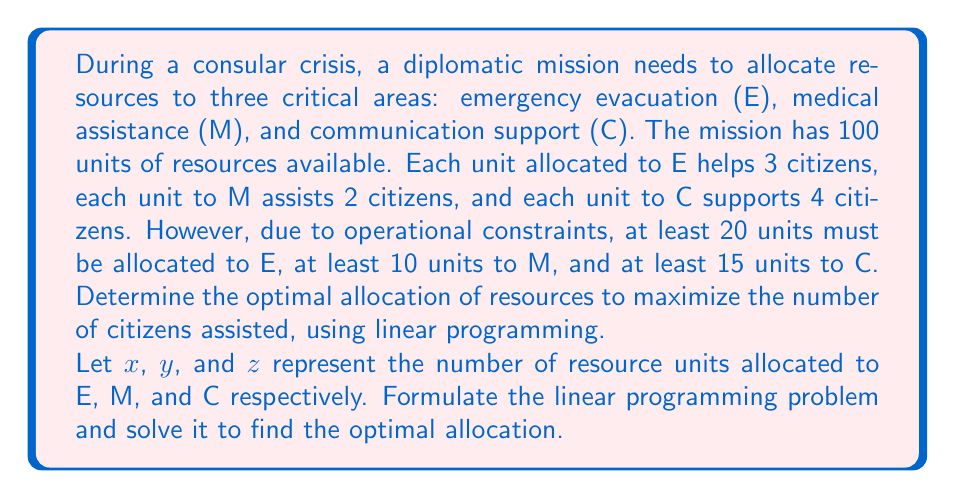Solve this math problem. To solve this problem using linear programming, we need to follow these steps:

1. Define the objective function:
   Maximize $f(x,y,z) = 3x + 2y + 4z$

2. Identify the constraints:
   $x + y + z \leq 100$ (total available resources)
   $x \geq 20$ (minimum for E)
   $y \geq 10$ (minimum for M)
   $z \geq 15$ (minimum for C)
   $x, y, z \geq 0$ (non-negativity constraints)

3. Set up the linear programming problem:
   Maximize $f(x,y,z) = 3x + 2y + 4z$
   Subject to:
   $$\begin{align}
   x + y + z &\leq 100 \\
   x &\geq 20 \\
   y &\geq 10 \\
   z &\geq 15 \\
   x, y, z &\geq 0
   \end{align}$$

4. Solve using the simplex method or graphical method:
   The optimal solution can be found at the corner points of the feasible region. We can use the following approach:
   
   a. Start with the minimum required allocation: $x = 20$, $y = 10$, $z = 15$
   b. We have 55 units left to allocate: $100 - (20 + 10 + 15) = 55$
   c. To maximize the objective function, we should allocate the remaining units to C, as it has the highest coefficient (4)
   d. Allocate the remaining 55 units to C: $z = 15 + 55 = 70$

5. The optimal solution is:
   $x = 20$ (E)
   $y = 10$ (M)
   $z = 70$ (C)

6. Calculate the maximum number of citizens assisted:
   $f(20, 10, 70) = 3(20) + 2(10) + 4(70) = 60 + 20 + 280 = 360$
Answer: The optimal allocation of resources is 20 units to emergency evacuation (E), 10 units to medical assistance (M), and 70 units to communication support (C). This allocation will assist a maximum of 360 citizens. 